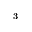<formula> <loc_0><loc_0><loc_500><loc_500>_ { 3 }</formula> 